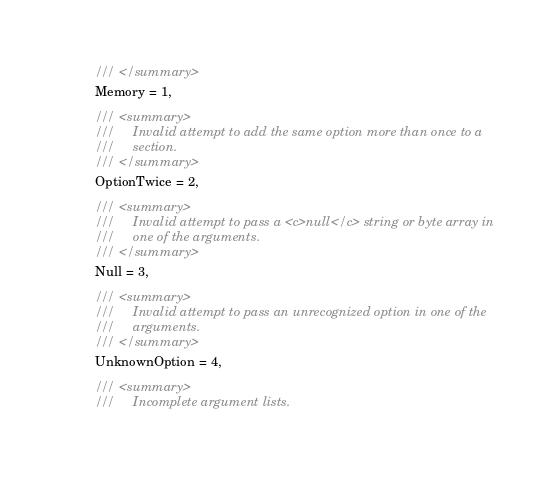Convert code to text. <code><loc_0><loc_0><loc_500><loc_500><_C#_>        /// </summary>
        Memory = 1,

        /// <summary>
        ///     Invalid attempt to add the same option more than once to a
        ///     section.
        /// </summary>
        OptionTwice = 2,

        /// <summary>
        ///     Invalid attempt to pass a <c>null</c> string or byte array in
        ///     one of the arguments.
        /// </summary>
        Null = 3,

        /// <summary>
        ///     Invalid attempt to pass an unrecognized option in one of the
        ///     arguments.
        /// </summary>
        UnknownOption = 4,

        /// <summary>
        ///     Incomplete argument lists.</code> 